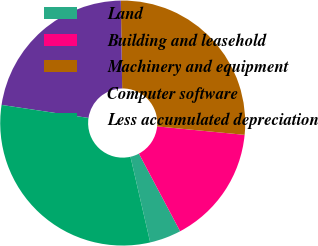Convert chart to OTSL. <chart><loc_0><loc_0><loc_500><loc_500><pie_chart><fcel>Land<fcel>Building and leasehold<fcel>Machinery and equipment<fcel>Computer software<fcel>Less accumulated depreciation<nl><fcel>4.16%<fcel>15.7%<fcel>26.78%<fcel>22.39%<fcel>30.97%<nl></chart> 